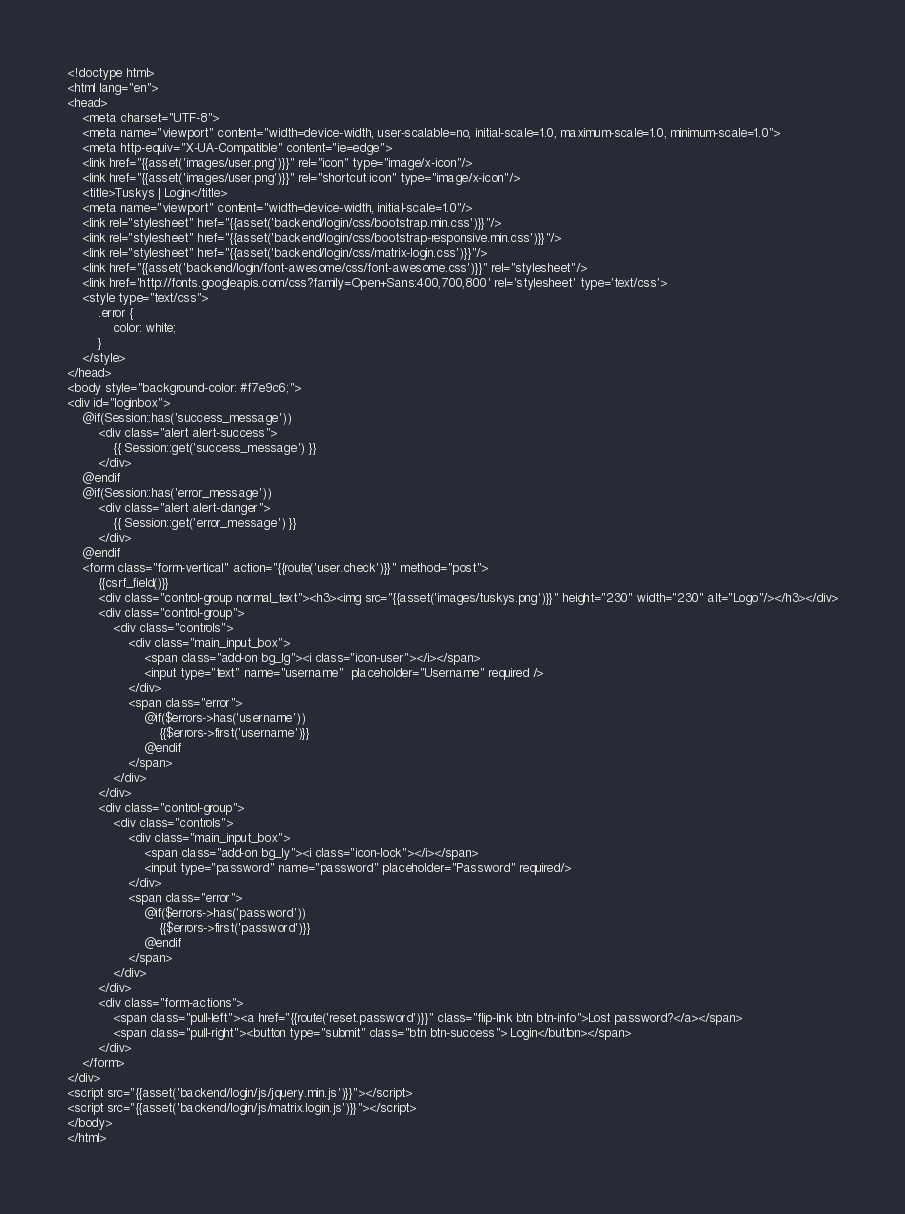<code> <loc_0><loc_0><loc_500><loc_500><_PHP_><!doctype html>
<html lang="en">
<head>
    <meta charset="UTF-8">
    <meta name="viewport" content="width=device-width, user-scalable=no, initial-scale=1.0, maximum-scale=1.0, minimum-scale=1.0">
    <meta http-equiv="X-UA-Compatible" content="ie=edge">
    <link href="{{asset('images/user.png')}}" rel="icon" type="image/x-icon"/>
    <link href="{{asset('images/user.png')}}" rel="shortcut icon" type="image/x-icon"/>
    <title>Tuskys | Login</title>
    <meta name="viewport" content="width=device-width, initial-scale=1.0"/>
    <link rel="stylesheet" href="{{asset('backend/login/css/bootstrap.min.css')}}"/>
    <link rel="stylesheet" href="{{asset('backend/login/css/bootstrap-responsive.min.css')}}"/>
    <link rel="stylesheet" href="{{asset('backend/login/css/matrix-login.css')}}"/>
    <link href="{{asset('backend/login/font-awesome/css/font-awesome.css')}}" rel="stylesheet"/>
    <link href='http://fonts.googleapis.com/css?family=Open+Sans:400,700,800' rel='stylesheet' type='text/css'>
    <style type="text/css">
        .error {
            color: white;
        }
    </style>
</head>
<body style="background-color: #f7e9c6;">
<div id="loginbox">
    @if(Session::has('success_message'))
        <div class="alert alert-success">
            {{ Session::get('success_message') }}
        </div>
    @endif
    @if(Session::has('error_message'))
        <div class="alert alert-danger">
            {{ Session::get('error_message') }}
        </div>
    @endif
    <form class="form-vertical" action="{{route('user.check')}}" method="post">
        {{csrf_field()}}
        <div class="control-group normal_text"><h3><img src="{{asset('images/tuskys.png')}}" height="230" width="230" alt="Logo"/></h3></div>
        <div class="control-group">
            <div class="controls">
                <div class="main_input_box">
                    <span class="add-on bg_lg"><i class="icon-user"></i></span>
                    <input type="text" name="username"  placeholder="Username" required />
                </div>
                <span class="error">
                    @if($errors->has('username'))
                        {{$errors->first('username')}}
                    @endif
                </span>
            </div>
        </div>
        <div class="control-group">
            <div class="controls">
                <div class="main_input_box">
                    <span class="add-on bg_ly"><i class="icon-lock"></i></span>
                    <input type="password" name="password" placeholder="Password" required/>
                </div>
                <span class="error">
                    @if($errors->has('password'))
                        {{$errors->first('password')}}
                    @endif
                </span>
            </div>
        </div>
        <div class="form-actions">
            <span class="pull-left"><a href="{{route('reset.password')}}" class="flip-link btn btn-info">Lost password?</a></span>
            <span class="pull-right"><button type="submit" class="btn btn-success"> Login</button></span>
        </div>
    </form>
</div>
<script src="{{asset('backend/login/js/jquery.min.js')}}"></script>
<script src="{{asset('backend/login/js/matrix.login.js')}}"></script>
</body>
</html>
</code> 